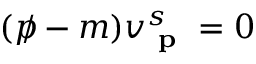<formula> <loc_0><loc_0><loc_500><loc_500>( p \, / - m ) v _ { p } ^ { s } = 0</formula> 